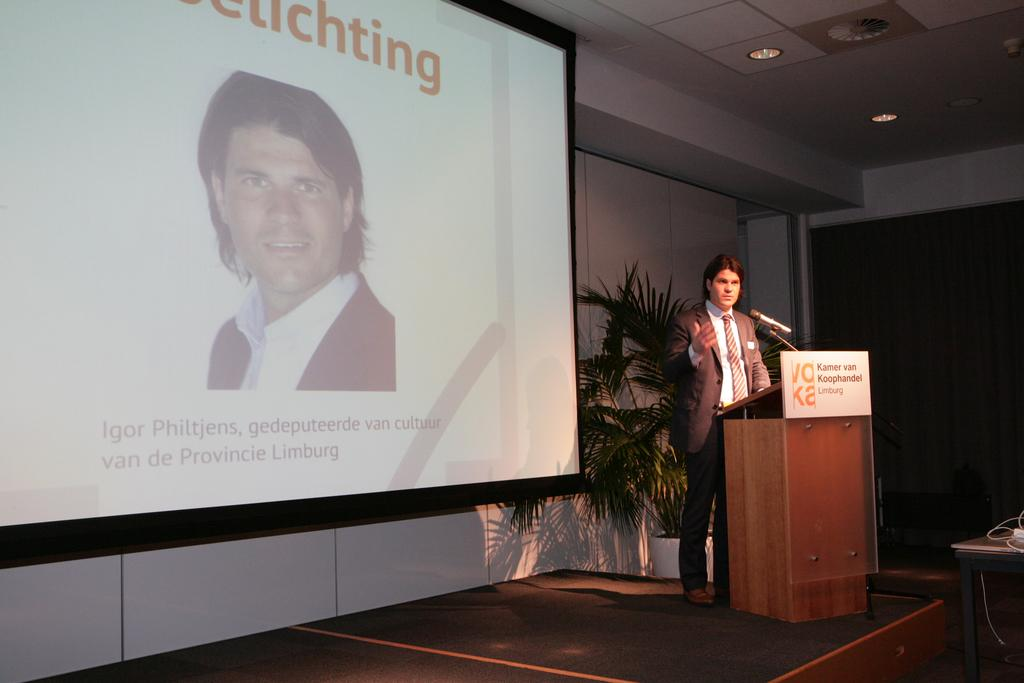What is the person in the image doing? The person is standing at a desk on the right side of the image. What can be seen in the background of the image? There is a houseplant, a curtain, a door, a screen, and a wall in the background of the image. What type of invention can be seen on the desk in the image? There is no invention visible on the desk in the image; only a person standing at the desk is present. What sound can be heard from the bells in the image? There are no bells present in the image, so no sound can be heard. 